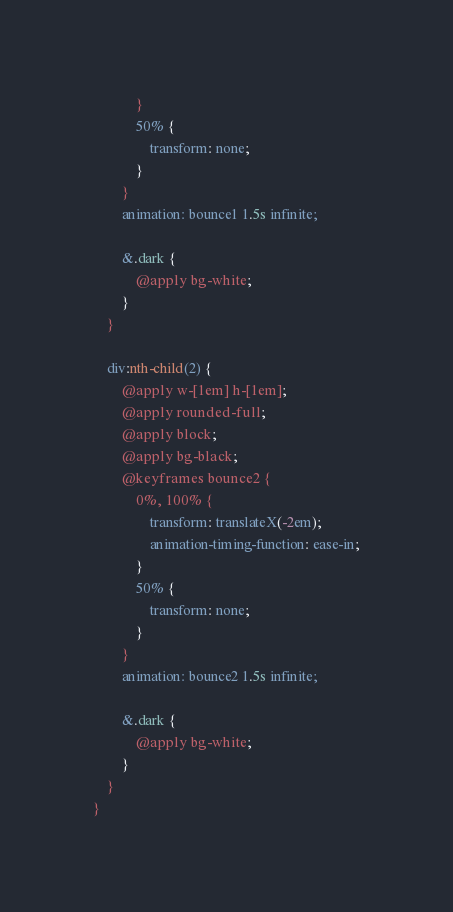<code> <loc_0><loc_0><loc_500><loc_500><_CSS_>            }
            50% {
                transform: none;
            }
        }
        animation: bounce1 1.5s infinite;

        &.dark {
            @apply bg-white;
        }
    }

    div:nth-child(2) {
        @apply w-[1em] h-[1em];
        @apply rounded-full;
        @apply block;
        @apply bg-black;
        @keyframes bounce2 {
            0%, 100% {
                transform: translateX(-2em);
                animation-timing-function: ease-in;
            }
            50% {
                transform: none;
            }
        }
        animation: bounce2 1.5s infinite;

        &.dark {
            @apply bg-white;
        }
    }
}
</code> 